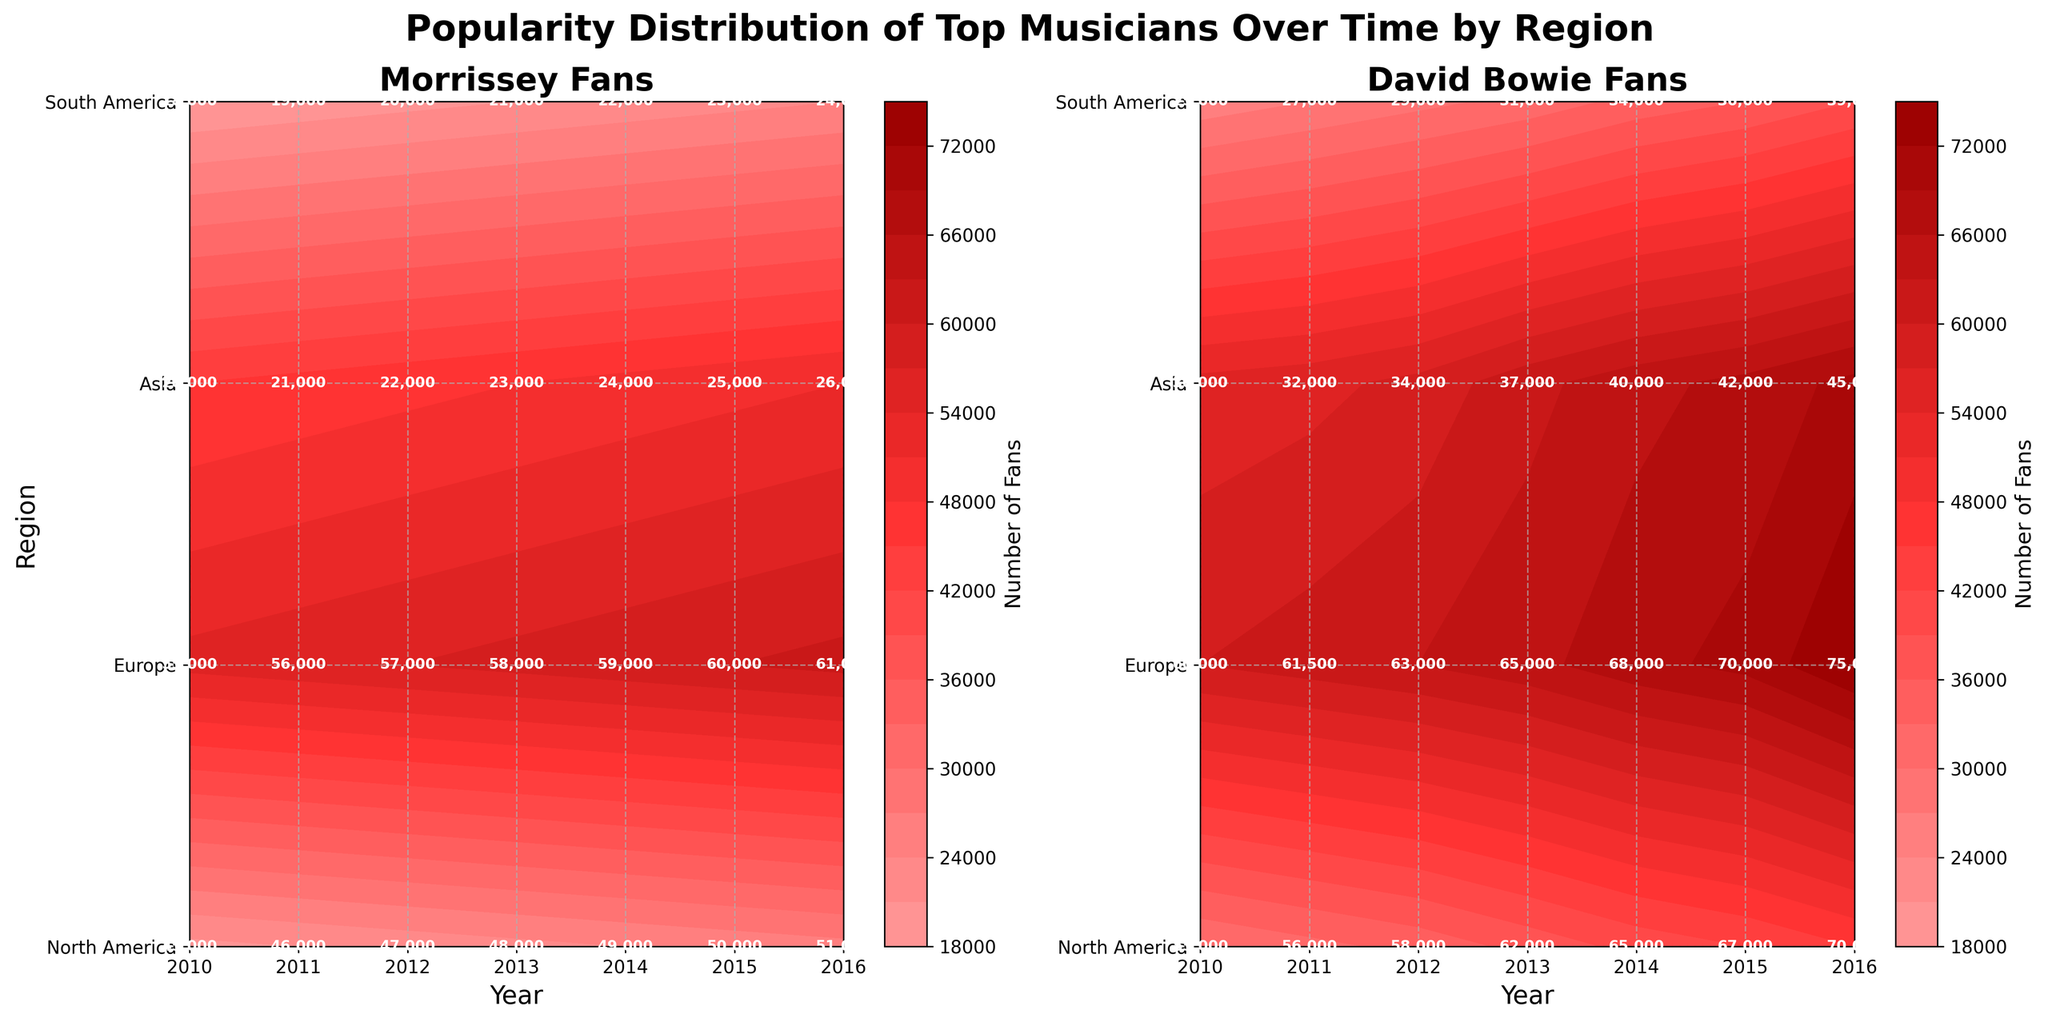How many regions are represented in the figure? The figure's y-axis shows different regions, which can be counted to determine the number. The y-axis ticks show four unique regions.
Answer: 4 Which year shows the highest number of Morrissey fans in Europe? By examining the contour labels on the plot for Morrissey Fans, we notice that the highest number of fans in Europe is marked in the year 2016. This is confirmed as the labels increase progressively up to this point.
Answer: 2016 How does the number of David Bowie fans in North America in 2013 compare to that in Asia in 2013? We look at the contour labels for David Bowie fans corresponding to the two regions in 2013. For North America, the value is labeled as 62,000, while for Asia, it is marked as 37,000. Comparing them shows that North America has more fans.
Answer: North America has more fans What is the difference in the number of Morrissey fans between South America and Europe in the year 2012? Checking the contour labels for Morrissey Fans in 2012, South America has 20,000 fans, and Europe has 57,000 fans. Subtracting these gives the difference: 57,000 - 20,000 = 37,000.
Answer: 37,000 Which region saw the most significant increase in David Bowie fans from 2010 to 2016? By assessing the contour labels for David Bowie fans over the years 2010 to 2016 across regions, Europe shows an increase from 60,000 to 75,000, which is a 15,000 increase. Other regions show lesser increases.
Answer: Europe What trend can be observed for Morrissey fans in North America from 2010 to 2016? By looking at the contour labels for Morrissey Fans in North America over these years, we see a steady increase from 45,000 in 2010 to 51,000 in 2016.
Answer: Steady increase What is the total number of Morrissey and David Bowie fans in South America in 2014? By checking the contour labels for both Morrissey and David Bowie fans in South America for the year 2014, we see 22,000 Morrissey fans and 34,000 David Bowie fans. Adding them gives 22,000 + 34,000 = 56,000.
Answer: 56,000 Which year had the lowest combined total of Morrissey and David Bowie fans in Asia? Reviewing the contour labels under Asia for each year, we sum Morrissey and David Bowie fans, finding the lowest combined total for 2010 (20,000 Morrissey, 30,000 Bowie), leading to the total being 50,000.
Answer: 2010 